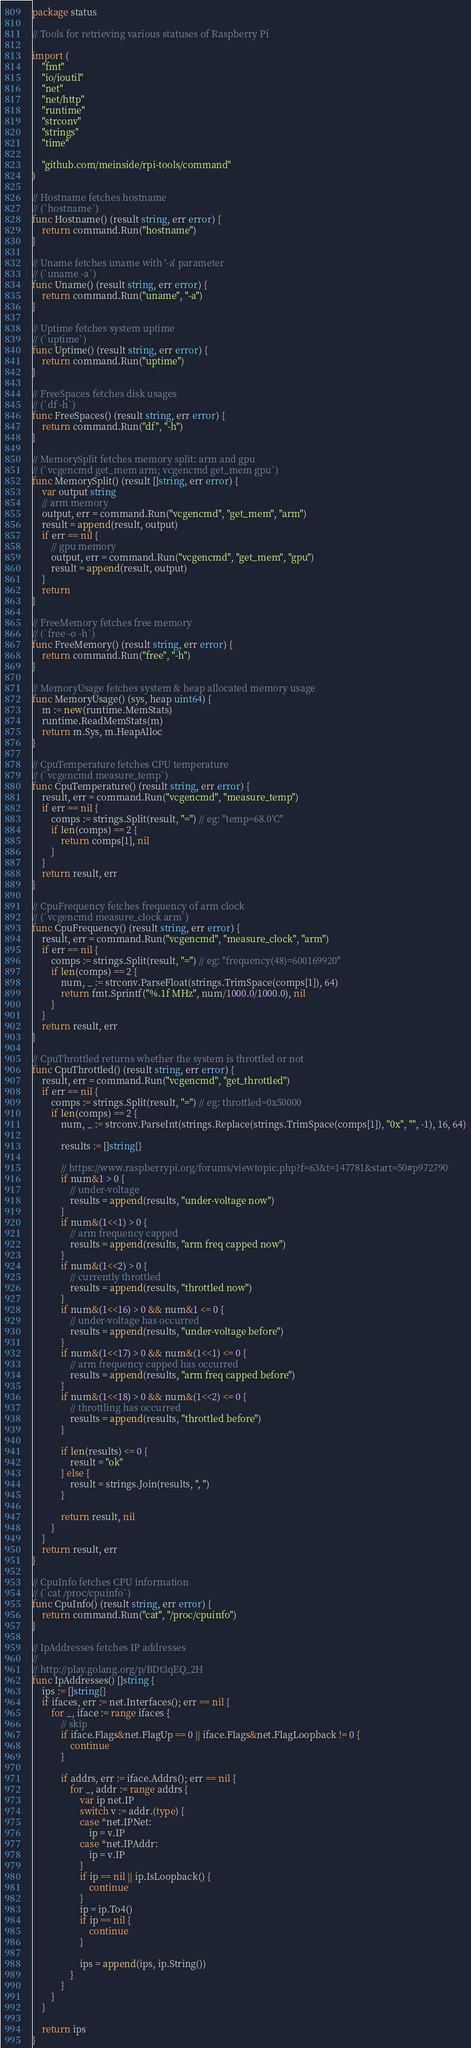<code> <loc_0><loc_0><loc_500><loc_500><_Go_>package status

// Tools for retrieving various statuses of Raspberry Pi

import (
	"fmt"
	"io/ioutil"
	"net"
	"net/http"
	"runtime"
	"strconv"
	"strings"
	"time"

	"github.com/meinside/rpi-tools/command"
)

// Hostname fetches hostname
// (`hostname`)
func Hostname() (result string, err error) {
	return command.Run("hostname")
}

// Uname fetches uname with '-a' parameter
// (`uname -a`)
func Uname() (result string, err error) {
	return command.Run("uname", "-a")
}

// Uptime fetches system uptime
// (`uptime`)
func Uptime() (result string, err error) {
	return command.Run("uptime")
}

// FreeSpaces fetches disk usages
// (`df -h`)
func FreeSpaces() (result string, err error) {
	return command.Run("df", "-h")
}

// MemorySplit fetches memory split: arm and gpu
// (`vcgencmd get_mem arm; vcgencmd get_mem gpu`)
func MemorySplit() (result []string, err error) {
	var output string
	// arm memory
	output, err = command.Run("vcgencmd", "get_mem", "arm")
	result = append(result, output)
	if err == nil {
		// gpu memory
		output, err = command.Run("vcgencmd", "get_mem", "gpu")
		result = append(result, output)
	}
	return
}

// FreeMemory fetches free memory
// (`free -o -h`)
func FreeMemory() (result string, err error) {
	return command.Run("free", "-h")
}

// MemoryUsage fetches system & heap allocated memory usage
func MemoryUsage() (sys, heap uint64) {
	m := new(runtime.MemStats)
	runtime.ReadMemStats(m)
	return m.Sys, m.HeapAlloc
}

// CpuTemperature fetches CPU temperature
// (`vcgencmd measure_temp`)
func CpuTemperature() (result string, err error) {
	result, err = command.Run("vcgencmd", "measure_temp")
	if err == nil {
		comps := strings.Split(result, "=") // eg: "temp=68.0'C"
		if len(comps) == 2 {
			return comps[1], nil
		}
	}
	return result, err
}

// CpuFrequency fetches frequency of arm clock
// (`vcgencmd measure_clock arm`)
func CpuFrequency() (result string, err error) {
	result, err = command.Run("vcgencmd", "measure_clock", "arm")
	if err == nil {
		comps := strings.Split(result, "=") // eg: "frequency(48)=600169920"
		if len(comps) == 2 {
			num, _ := strconv.ParseFloat(strings.TrimSpace(comps[1]), 64)
			return fmt.Sprintf("%.1f MHz", num/1000.0/1000.0), nil
		}
	}
	return result, err
}

// CpuThrottled returns whether the system is throttled or not
func CpuThrottled() (result string, err error) {
	result, err = command.Run("vcgencmd", "get_throttled")
	if err == nil {
		comps := strings.Split(result, "=") // eg: throttled=0x50000
		if len(comps) == 2 {
			num, _ := strconv.ParseInt(strings.Replace(strings.TrimSpace(comps[1]), "0x", "", -1), 16, 64)

			results := []string{}

			// https://www.raspberrypi.org/forums/viewtopic.php?f=63&t=147781&start=50#p972790
			if num&1 > 0 {
				// under-voltage
				results = append(results, "under-voltage now")
			}
			if num&(1<<1) > 0 {
				// arm frequency capped
				results = append(results, "arm freq capped now")
			}
			if num&(1<<2) > 0 {
				// currently throttled
				results = append(results, "throttled now")
			}
			if num&(1<<16) > 0 && num&1 <= 0 {
				// under-voltage has occurred
				results = append(results, "under-voltage before")
			}
			if num&(1<<17) > 0 && num&(1<<1) <= 0 {
				// arm frequency capped has occurred
				results = append(results, "arm freq capped before")
			}
			if num&(1<<18) > 0 && num&(1<<2) <= 0 {
				// throttling has occurred
				results = append(results, "throttled before")
			}

			if len(results) <= 0 {
				result = "ok"
			} else {
				result = strings.Join(results, ", ")
			}

			return result, nil
		}
	}
	return result, err
}

// CpuInfo fetches CPU information
// (`cat /proc/cpuinfo`)
func CpuInfo() (result string, err error) {
	return command.Run("cat", "/proc/cpuinfo")
}

// IpAddresses fetches IP addresses
//
// http://play.golang.org/p/BDt3qEQ_2H
func IpAddresses() []string {
	ips := []string{}
	if ifaces, err := net.Interfaces(); err == nil {
		for _, iface := range ifaces {
			// skip
			if iface.Flags&net.FlagUp == 0 || iface.Flags&net.FlagLoopback != 0 {
				continue
			}

			if addrs, err := iface.Addrs(); err == nil {
				for _, addr := range addrs {
					var ip net.IP
					switch v := addr.(type) {
					case *net.IPNet:
						ip = v.IP
					case *net.IPAddr:
						ip = v.IP
					}
					if ip == nil || ip.IsLoopback() {
						continue
					}
					ip = ip.To4()
					if ip == nil {
						continue
					}

					ips = append(ips, ip.String())
				}
			}
		}
	}

	return ips
}
</code> 